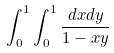<formula> <loc_0><loc_0><loc_500><loc_500>\int _ { 0 } ^ { 1 } \int _ { 0 } ^ { 1 } \frac { d x d y } { 1 - x y }</formula> 